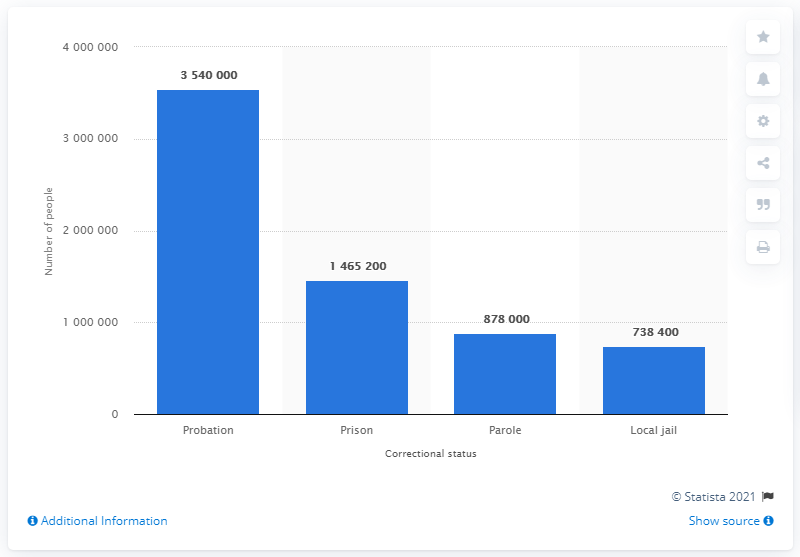Point out several critical features in this image. In 2018, approximately 354,000 Americans were on probation. 